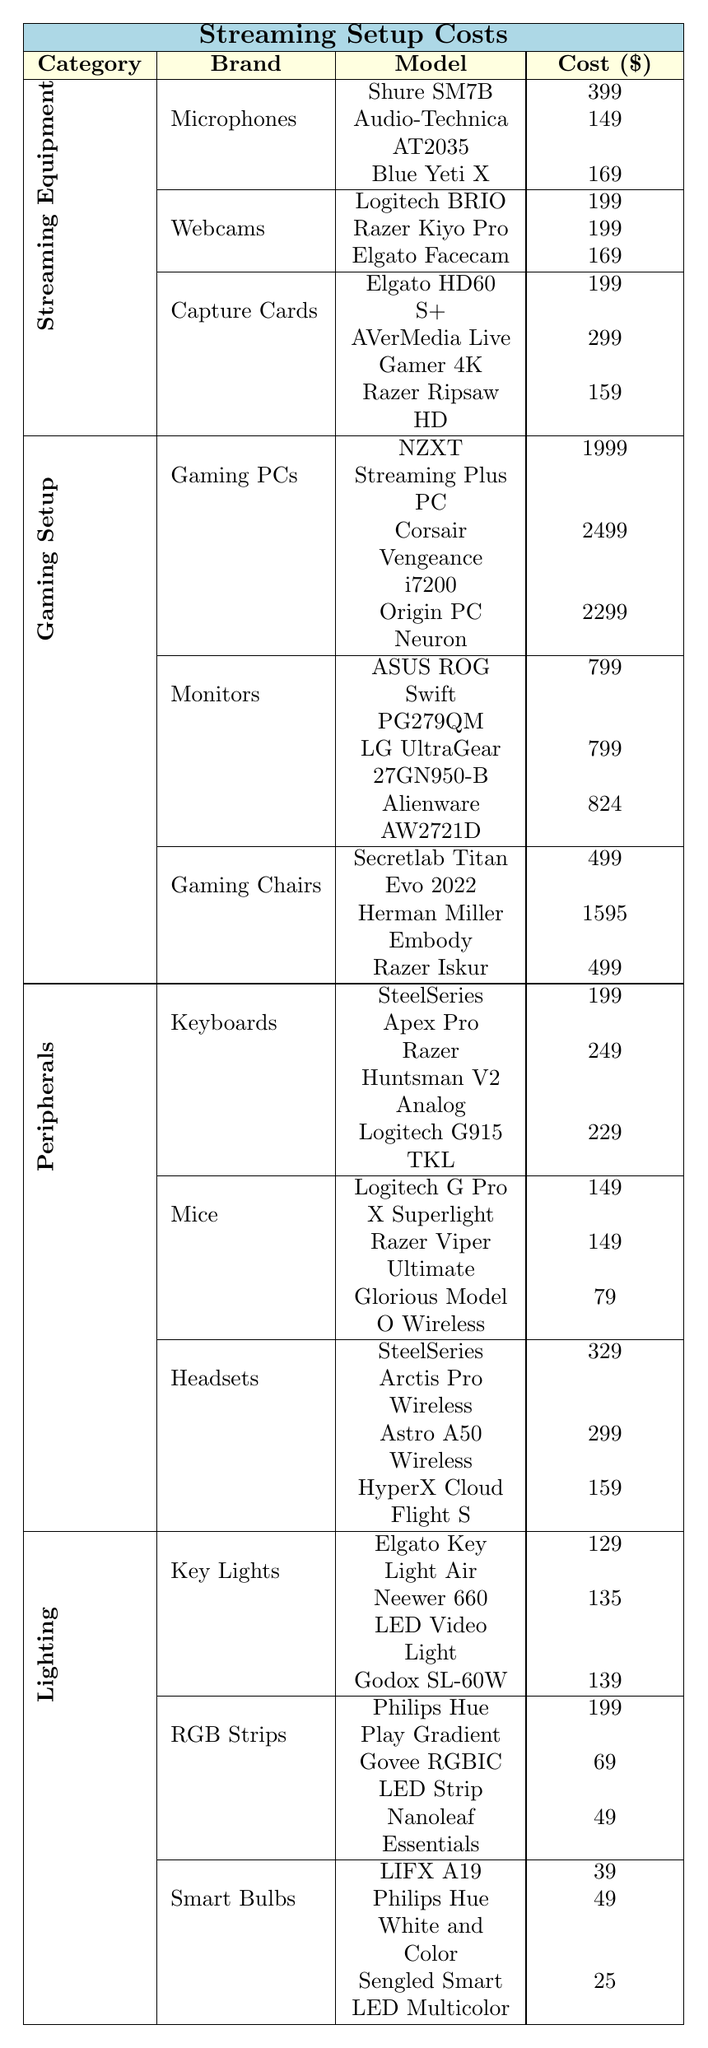What is the cost of the Shure SM7B microphone? The table shows that the Shure SM7B microphone is listed under the Microphones category and has a cost of $399.
Answer: 399 Which has a higher price: AVerMedia Live Gamer 4K or Razer Ripsaw HD? According to the table, AVerMedia Live Gamer 4K costs $299, while Razer Ripsaw HD costs $159. Since $299 is greater than $159, the AVerMedia is the more expensive option.
Answer: AVerMedia Live Gamer 4K What is the total cost of all the Gaming PCs listed? The table lists three Gaming PCs: NZXT Streaming Plus PC ($1999), Corsair Vengeance i7200 ($2499), and Origin PC Neuron ($2299). Adding them gives: 1999 + 2499 + 2299 = 6797.
Answer: 6797 Is the Logitech G Pro X Superlight mouse cheaper than the SteelSeries Apex Pro keyboard? The Logitech G Pro X Superlight mouse costs $149 and the SteelSeries Apex Pro keyboard costs $199. Since $149 is less than $199, the mouse is indeed cheaper.
Answer: Yes What is the average cost of the Monitors listed in the table? The Monitors listed are: ASUS ROG Swift PG279QM ($799), LG UltraGear 27GN950-B ($799), and Alienware AW2721D ($824). The total cost is 799 + 799 + 824 = 2422, and there are 3 monitors. Therefore, the average cost is 2422 / 3 = 807.33.
Answer: 807.33 Which category has the most expensive item, and what is the cost? By comparing the highest priced items in each category: Gaming PCs has Corsair Vengeance i7200 ($2499), Microphones has Shure SM7B ($399), etc. The Corsair Vengeance i7200 is the most expensive at $2499.
Answer: Gaming Setup, 2499 If I have a budget of $500 for a gaming chair, which options can I consider? The table lists two gaming chairs under $500: Secretlab Titan Evo 2022 and Razer Iskur, both priced at $499. Therefore, both options fit within the budget.
Answer: Secretlab Titan Evo 2022, Razer Iskur What is the price difference between the most expensive and least expensive RGB strip? The most expensive RGB strip is Philips Hue Play Gradient at $199, and the least expensive is Govee RGBIC LED Strip at $69. The price difference is 199 - 69 = 130.
Answer: 130 Are there any Smart Bulbs priced below $50? The table shows three Smart Bulbs: LIFX A19 ($39), Philips Hue White and Color ($49), and Sengled Smart LED Multicolor ($25). All are below $50, confirming that there are options available.
Answer: Yes What is the second most expensive headset? The headsets listed are: SteelSeries Arctis Pro Wireless ($329), Astro A50 Wireless ($299), and HyperX Cloud Flight S ($159). The second most expensive headset is Astro A50 Wireless at $299.
Answer: Astro A50 Wireless 